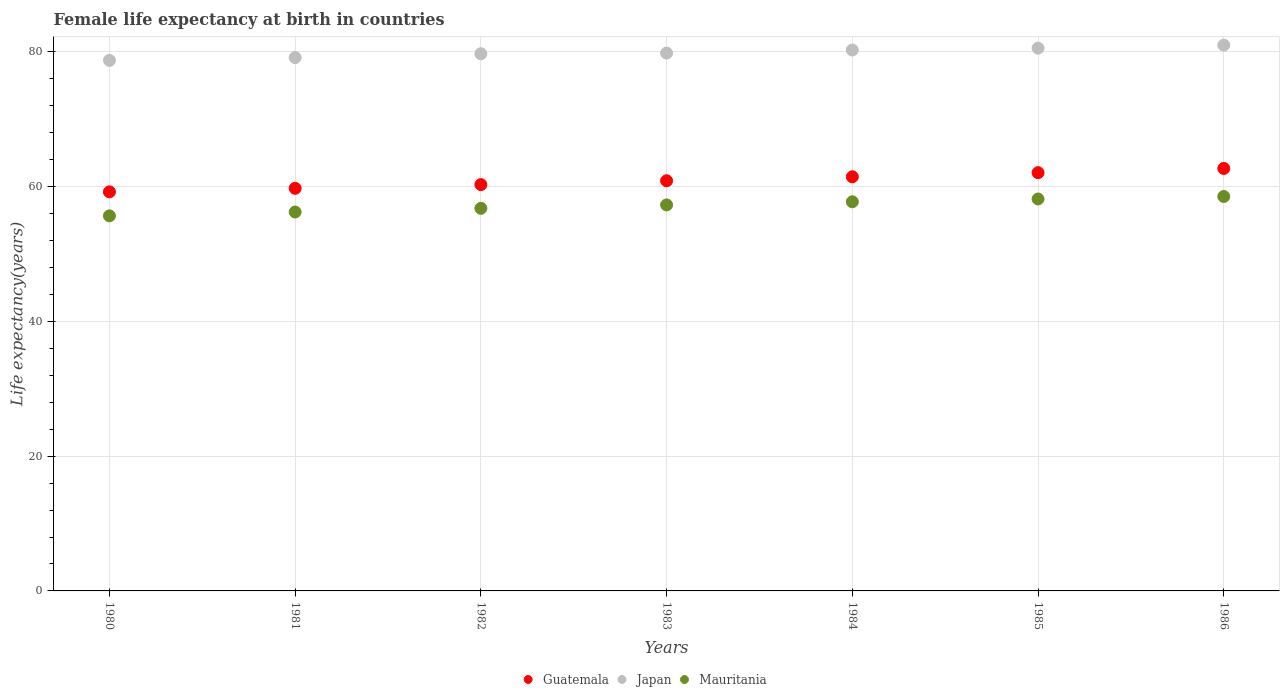What is the female life expectancy at birth in Japan in 1986?
Provide a short and direct response. 81.02. Across all years, what is the maximum female life expectancy at birth in Japan?
Your response must be concise. 81.02. Across all years, what is the minimum female life expectancy at birth in Japan?
Your answer should be compact. 78.75. In which year was the female life expectancy at birth in Japan minimum?
Your answer should be compact. 1980. What is the total female life expectancy at birth in Japan in the graph?
Provide a short and direct response. 559.38. What is the difference between the female life expectancy at birth in Japan in 1981 and that in 1982?
Your answer should be very brief. -0.57. What is the difference between the female life expectancy at birth in Japan in 1984 and the female life expectancy at birth in Guatemala in 1982?
Ensure brevity in your answer.  19.98. What is the average female life expectancy at birth in Japan per year?
Your response must be concise. 79.91. In the year 1982, what is the difference between the female life expectancy at birth in Mauritania and female life expectancy at birth in Guatemala?
Make the answer very short. -3.52. In how many years, is the female life expectancy at birth in Japan greater than 44 years?
Keep it short and to the point. 7. What is the ratio of the female life expectancy at birth in Guatemala in 1981 to that in 1982?
Offer a very short reply. 0.99. Is the female life expectancy at birth in Guatemala in 1983 less than that in 1986?
Give a very brief answer. Yes. What is the difference between the highest and the second highest female life expectancy at birth in Japan?
Keep it short and to the point. 0.45. What is the difference between the highest and the lowest female life expectancy at birth in Japan?
Give a very brief answer. 2.27. In how many years, is the female life expectancy at birth in Mauritania greater than the average female life expectancy at birth in Mauritania taken over all years?
Offer a very short reply. 4. Is the sum of the female life expectancy at birth in Japan in 1983 and 1985 greater than the maximum female life expectancy at birth in Mauritania across all years?
Give a very brief answer. Yes. Does the female life expectancy at birth in Guatemala monotonically increase over the years?
Offer a terse response. Yes. Is the female life expectancy at birth in Guatemala strictly less than the female life expectancy at birth in Japan over the years?
Offer a very short reply. Yes. What is the difference between two consecutive major ticks on the Y-axis?
Your answer should be compact. 20. Does the graph contain any zero values?
Your answer should be very brief. No. Does the graph contain grids?
Your answer should be very brief. Yes. How are the legend labels stacked?
Provide a short and direct response. Horizontal. What is the title of the graph?
Keep it short and to the point. Female life expectancy at birth in countries. Does "Costa Rica" appear as one of the legend labels in the graph?
Make the answer very short. No. What is the label or title of the Y-axis?
Your answer should be very brief. Life expectancy(years). What is the Life expectancy(years) in Guatemala in 1980?
Provide a succinct answer. 59.24. What is the Life expectancy(years) of Japan in 1980?
Make the answer very short. 78.75. What is the Life expectancy(years) of Mauritania in 1980?
Your response must be concise. 55.67. What is the Life expectancy(years) of Guatemala in 1981?
Provide a short and direct response. 59.76. What is the Life expectancy(years) of Japan in 1981?
Your response must be concise. 79.17. What is the Life expectancy(years) in Mauritania in 1981?
Ensure brevity in your answer.  56.25. What is the Life expectancy(years) of Guatemala in 1982?
Offer a very short reply. 60.31. What is the Life expectancy(years) in Japan in 1982?
Your answer should be very brief. 79.74. What is the Life expectancy(years) in Mauritania in 1982?
Ensure brevity in your answer.  56.79. What is the Life expectancy(years) of Guatemala in 1983?
Your answer should be very brief. 60.88. What is the Life expectancy(years) in Japan in 1983?
Your answer should be compact. 79.84. What is the Life expectancy(years) of Mauritania in 1983?
Your answer should be very brief. 57.3. What is the Life expectancy(years) of Guatemala in 1984?
Give a very brief answer. 61.48. What is the Life expectancy(years) of Japan in 1984?
Your answer should be compact. 80.29. What is the Life expectancy(years) in Mauritania in 1984?
Provide a short and direct response. 57.76. What is the Life expectancy(years) of Guatemala in 1985?
Provide a short and direct response. 62.09. What is the Life expectancy(years) in Japan in 1985?
Offer a very short reply. 80.57. What is the Life expectancy(years) of Mauritania in 1985?
Your answer should be very brief. 58.18. What is the Life expectancy(years) in Guatemala in 1986?
Provide a short and direct response. 62.71. What is the Life expectancy(years) of Japan in 1986?
Keep it short and to the point. 81.02. What is the Life expectancy(years) of Mauritania in 1986?
Offer a very short reply. 58.55. Across all years, what is the maximum Life expectancy(years) in Guatemala?
Provide a short and direct response. 62.71. Across all years, what is the maximum Life expectancy(years) in Japan?
Keep it short and to the point. 81.02. Across all years, what is the maximum Life expectancy(years) of Mauritania?
Provide a succinct answer. 58.55. Across all years, what is the minimum Life expectancy(years) in Guatemala?
Make the answer very short. 59.24. Across all years, what is the minimum Life expectancy(years) of Japan?
Make the answer very short. 78.75. Across all years, what is the minimum Life expectancy(years) in Mauritania?
Make the answer very short. 55.67. What is the total Life expectancy(years) of Guatemala in the graph?
Your answer should be compact. 426.47. What is the total Life expectancy(years) in Japan in the graph?
Ensure brevity in your answer.  559.38. What is the total Life expectancy(years) in Mauritania in the graph?
Your answer should be very brief. 400.5. What is the difference between the Life expectancy(years) of Guatemala in 1980 and that in 1981?
Keep it short and to the point. -0.53. What is the difference between the Life expectancy(years) of Japan in 1980 and that in 1981?
Your response must be concise. -0.42. What is the difference between the Life expectancy(years) of Mauritania in 1980 and that in 1981?
Your answer should be compact. -0.57. What is the difference between the Life expectancy(years) in Guatemala in 1980 and that in 1982?
Your response must be concise. -1.07. What is the difference between the Life expectancy(years) of Japan in 1980 and that in 1982?
Keep it short and to the point. -0.99. What is the difference between the Life expectancy(years) of Mauritania in 1980 and that in 1982?
Ensure brevity in your answer.  -1.12. What is the difference between the Life expectancy(years) of Guatemala in 1980 and that in 1983?
Your answer should be very brief. -1.65. What is the difference between the Life expectancy(years) in Japan in 1980 and that in 1983?
Your answer should be compact. -1.09. What is the difference between the Life expectancy(years) of Mauritania in 1980 and that in 1983?
Keep it short and to the point. -1.63. What is the difference between the Life expectancy(years) in Guatemala in 1980 and that in 1984?
Make the answer very short. -2.24. What is the difference between the Life expectancy(years) in Japan in 1980 and that in 1984?
Offer a terse response. -1.54. What is the difference between the Life expectancy(years) in Mauritania in 1980 and that in 1984?
Provide a succinct answer. -2.09. What is the difference between the Life expectancy(years) in Guatemala in 1980 and that in 1985?
Your answer should be compact. -2.85. What is the difference between the Life expectancy(years) of Japan in 1980 and that in 1985?
Offer a terse response. -1.82. What is the difference between the Life expectancy(years) of Mauritania in 1980 and that in 1985?
Offer a very short reply. -2.51. What is the difference between the Life expectancy(years) of Guatemala in 1980 and that in 1986?
Ensure brevity in your answer.  -3.47. What is the difference between the Life expectancy(years) in Japan in 1980 and that in 1986?
Offer a very short reply. -2.27. What is the difference between the Life expectancy(years) of Mauritania in 1980 and that in 1986?
Your answer should be compact. -2.88. What is the difference between the Life expectancy(years) in Guatemala in 1981 and that in 1982?
Make the answer very short. -0.55. What is the difference between the Life expectancy(years) in Japan in 1981 and that in 1982?
Your answer should be compact. -0.57. What is the difference between the Life expectancy(years) of Mauritania in 1981 and that in 1982?
Your answer should be compact. -0.55. What is the difference between the Life expectancy(years) in Guatemala in 1981 and that in 1983?
Provide a succinct answer. -1.12. What is the difference between the Life expectancy(years) of Japan in 1981 and that in 1983?
Offer a terse response. -0.67. What is the difference between the Life expectancy(years) of Mauritania in 1981 and that in 1983?
Your answer should be very brief. -1.05. What is the difference between the Life expectancy(years) in Guatemala in 1981 and that in 1984?
Offer a very short reply. -1.71. What is the difference between the Life expectancy(years) of Japan in 1981 and that in 1984?
Offer a very short reply. -1.12. What is the difference between the Life expectancy(years) of Mauritania in 1981 and that in 1984?
Provide a short and direct response. -1.52. What is the difference between the Life expectancy(years) in Guatemala in 1981 and that in 1985?
Provide a succinct answer. -2.32. What is the difference between the Life expectancy(years) in Mauritania in 1981 and that in 1985?
Ensure brevity in your answer.  -1.94. What is the difference between the Life expectancy(years) in Guatemala in 1981 and that in 1986?
Offer a very short reply. -2.94. What is the difference between the Life expectancy(years) in Japan in 1981 and that in 1986?
Ensure brevity in your answer.  -1.85. What is the difference between the Life expectancy(years) in Mauritania in 1981 and that in 1986?
Offer a terse response. -2.3. What is the difference between the Life expectancy(years) of Guatemala in 1982 and that in 1983?
Make the answer very short. -0.57. What is the difference between the Life expectancy(years) of Mauritania in 1982 and that in 1983?
Ensure brevity in your answer.  -0.51. What is the difference between the Life expectancy(years) in Guatemala in 1982 and that in 1984?
Offer a terse response. -1.16. What is the difference between the Life expectancy(years) of Japan in 1982 and that in 1984?
Make the answer very short. -0.55. What is the difference between the Life expectancy(years) in Mauritania in 1982 and that in 1984?
Offer a very short reply. -0.97. What is the difference between the Life expectancy(years) in Guatemala in 1982 and that in 1985?
Ensure brevity in your answer.  -1.77. What is the difference between the Life expectancy(years) in Japan in 1982 and that in 1985?
Offer a very short reply. -0.83. What is the difference between the Life expectancy(years) of Mauritania in 1982 and that in 1985?
Keep it short and to the point. -1.39. What is the difference between the Life expectancy(years) in Guatemala in 1982 and that in 1986?
Offer a very short reply. -2.4. What is the difference between the Life expectancy(years) of Japan in 1982 and that in 1986?
Make the answer very short. -1.28. What is the difference between the Life expectancy(years) in Mauritania in 1982 and that in 1986?
Provide a succinct answer. -1.76. What is the difference between the Life expectancy(years) of Guatemala in 1983 and that in 1984?
Give a very brief answer. -0.59. What is the difference between the Life expectancy(years) of Japan in 1983 and that in 1984?
Provide a short and direct response. -0.45. What is the difference between the Life expectancy(years) in Mauritania in 1983 and that in 1984?
Offer a very short reply. -0.47. What is the difference between the Life expectancy(years) of Guatemala in 1983 and that in 1985?
Provide a succinct answer. -1.2. What is the difference between the Life expectancy(years) in Japan in 1983 and that in 1985?
Your answer should be compact. -0.73. What is the difference between the Life expectancy(years) in Mauritania in 1983 and that in 1985?
Give a very brief answer. -0.88. What is the difference between the Life expectancy(years) of Guatemala in 1983 and that in 1986?
Your answer should be very brief. -1.82. What is the difference between the Life expectancy(years) in Japan in 1983 and that in 1986?
Provide a short and direct response. -1.18. What is the difference between the Life expectancy(years) in Mauritania in 1983 and that in 1986?
Give a very brief answer. -1.25. What is the difference between the Life expectancy(years) of Guatemala in 1984 and that in 1985?
Make the answer very short. -0.61. What is the difference between the Life expectancy(years) in Japan in 1984 and that in 1985?
Your answer should be very brief. -0.28. What is the difference between the Life expectancy(years) in Mauritania in 1984 and that in 1985?
Offer a very short reply. -0.42. What is the difference between the Life expectancy(years) in Guatemala in 1984 and that in 1986?
Keep it short and to the point. -1.23. What is the difference between the Life expectancy(years) of Japan in 1984 and that in 1986?
Provide a succinct answer. -0.73. What is the difference between the Life expectancy(years) of Mauritania in 1984 and that in 1986?
Offer a very short reply. -0.79. What is the difference between the Life expectancy(years) in Guatemala in 1985 and that in 1986?
Make the answer very short. -0.62. What is the difference between the Life expectancy(years) of Japan in 1985 and that in 1986?
Give a very brief answer. -0.45. What is the difference between the Life expectancy(years) in Mauritania in 1985 and that in 1986?
Make the answer very short. -0.37. What is the difference between the Life expectancy(years) of Guatemala in 1980 and the Life expectancy(years) of Japan in 1981?
Make the answer very short. -19.93. What is the difference between the Life expectancy(years) in Guatemala in 1980 and the Life expectancy(years) in Mauritania in 1981?
Ensure brevity in your answer.  2.99. What is the difference between the Life expectancy(years) in Japan in 1980 and the Life expectancy(years) in Mauritania in 1981?
Your response must be concise. 22.5. What is the difference between the Life expectancy(years) of Guatemala in 1980 and the Life expectancy(years) of Japan in 1982?
Ensure brevity in your answer.  -20.5. What is the difference between the Life expectancy(years) of Guatemala in 1980 and the Life expectancy(years) of Mauritania in 1982?
Offer a terse response. 2.45. What is the difference between the Life expectancy(years) of Japan in 1980 and the Life expectancy(years) of Mauritania in 1982?
Give a very brief answer. 21.96. What is the difference between the Life expectancy(years) of Guatemala in 1980 and the Life expectancy(years) of Japan in 1983?
Your answer should be very brief. -20.6. What is the difference between the Life expectancy(years) in Guatemala in 1980 and the Life expectancy(years) in Mauritania in 1983?
Your response must be concise. 1.94. What is the difference between the Life expectancy(years) of Japan in 1980 and the Life expectancy(years) of Mauritania in 1983?
Give a very brief answer. 21.45. What is the difference between the Life expectancy(years) of Guatemala in 1980 and the Life expectancy(years) of Japan in 1984?
Your response must be concise. -21.05. What is the difference between the Life expectancy(years) of Guatemala in 1980 and the Life expectancy(years) of Mauritania in 1984?
Keep it short and to the point. 1.48. What is the difference between the Life expectancy(years) in Japan in 1980 and the Life expectancy(years) in Mauritania in 1984?
Offer a very short reply. 20.99. What is the difference between the Life expectancy(years) in Guatemala in 1980 and the Life expectancy(years) in Japan in 1985?
Offer a terse response. -21.33. What is the difference between the Life expectancy(years) in Guatemala in 1980 and the Life expectancy(years) in Mauritania in 1985?
Offer a very short reply. 1.06. What is the difference between the Life expectancy(years) in Japan in 1980 and the Life expectancy(years) in Mauritania in 1985?
Make the answer very short. 20.57. What is the difference between the Life expectancy(years) in Guatemala in 1980 and the Life expectancy(years) in Japan in 1986?
Offer a very short reply. -21.78. What is the difference between the Life expectancy(years) in Guatemala in 1980 and the Life expectancy(years) in Mauritania in 1986?
Offer a terse response. 0.69. What is the difference between the Life expectancy(years) of Japan in 1980 and the Life expectancy(years) of Mauritania in 1986?
Give a very brief answer. 20.2. What is the difference between the Life expectancy(years) of Guatemala in 1981 and the Life expectancy(years) of Japan in 1982?
Offer a very short reply. -19.98. What is the difference between the Life expectancy(years) of Guatemala in 1981 and the Life expectancy(years) of Mauritania in 1982?
Make the answer very short. 2.97. What is the difference between the Life expectancy(years) of Japan in 1981 and the Life expectancy(years) of Mauritania in 1982?
Keep it short and to the point. 22.38. What is the difference between the Life expectancy(years) of Guatemala in 1981 and the Life expectancy(years) of Japan in 1983?
Provide a succinct answer. -20.08. What is the difference between the Life expectancy(years) in Guatemala in 1981 and the Life expectancy(years) in Mauritania in 1983?
Your response must be concise. 2.46. What is the difference between the Life expectancy(years) in Japan in 1981 and the Life expectancy(years) in Mauritania in 1983?
Your answer should be very brief. 21.87. What is the difference between the Life expectancy(years) in Guatemala in 1981 and the Life expectancy(years) in Japan in 1984?
Your response must be concise. -20.53. What is the difference between the Life expectancy(years) of Guatemala in 1981 and the Life expectancy(years) of Mauritania in 1984?
Your response must be concise. 2. What is the difference between the Life expectancy(years) in Japan in 1981 and the Life expectancy(years) in Mauritania in 1984?
Offer a terse response. 21.41. What is the difference between the Life expectancy(years) of Guatemala in 1981 and the Life expectancy(years) of Japan in 1985?
Give a very brief answer. -20.81. What is the difference between the Life expectancy(years) in Guatemala in 1981 and the Life expectancy(years) in Mauritania in 1985?
Provide a short and direct response. 1.58. What is the difference between the Life expectancy(years) of Japan in 1981 and the Life expectancy(years) of Mauritania in 1985?
Make the answer very short. 20.99. What is the difference between the Life expectancy(years) of Guatemala in 1981 and the Life expectancy(years) of Japan in 1986?
Provide a succinct answer. -21.26. What is the difference between the Life expectancy(years) of Guatemala in 1981 and the Life expectancy(years) of Mauritania in 1986?
Make the answer very short. 1.22. What is the difference between the Life expectancy(years) of Japan in 1981 and the Life expectancy(years) of Mauritania in 1986?
Give a very brief answer. 20.62. What is the difference between the Life expectancy(years) of Guatemala in 1982 and the Life expectancy(years) of Japan in 1983?
Your answer should be compact. -19.53. What is the difference between the Life expectancy(years) in Guatemala in 1982 and the Life expectancy(years) in Mauritania in 1983?
Your answer should be very brief. 3.02. What is the difference between the Life expectancy(years) in Japan in 1982 and the Life expectancy(years) in Mauritania in 1983?
Keep it short and to the point. 22.44. What is the difference between the Life expectancy(years) in Guatemala in 1982 and the Life expectancy(years) in Japan in 1984?
Keep it short and to the point. -19.98. What is the difference between the Life expectancy(years) of Guatemala in 1982 and the Life expectancy(years) of Mauritania in 1984?
Offer a very short reply. 2.55. What is the difference between the Life expectancy(years) of Japan in 1982 and the Life expectancy(years) of Mauritania in 1984?
Keep it short and to the point. 21.98. What is the difference between the Life expectancy(years) of Guatemala in 1982 and the Life expectancy(years) of Japan in 1985?
Your response must be concise. -20.26. What is the difference between the Life expectancy(years) in Guatemala in 1982 and the Life expectancy(years) in Mauritania in 1985?
Give a very brief answer. 2.13. What is the difference between the Life expectancy(years) of Japan in 1982 and the Life expectancy(years) of Mauritania in 1985?
Provide a succinct answer. 21.56. What is the difference between the Life expectancy(years) in Guatemala in 1982 and the Life expectancy(years) in Japan in 1986?
Offer a terse response. -20.71. What is the difference between the Life expectancy(years) in Guatemala in 1982 and the Life expectancy(years) in Mauritania in 1986?
Offer a very short reply. 1.76. What is the difference between the Life expectancy(years) in Japan in 1982 and the Life expectancy(years) in Mauritania in 1986?
Your response must be concise. 21.19. What is the difference between the Life expectancy(years) of Guatemala in 1983 and the Life expectancy(years) of Japan in 1984?
Give a very brief answer. -19.41. What is the difference between the Life expectancy(years) in Guatemala in 1983 and the Life expectancy(years) in Mauritania in 1984?
Give a very brief answer. 3.12. What is the difference between the Life expectancy(years) of Japan in 1983 and the Life expectancy(years) of Mauritania in 1984?
Make the answer very short. 22.08. What is the difference between the Life expectancy(years) of Guatemala in 1983 and the Life expectancy(years) of Japan in 1985?
Offer a very short reply. -19.69. What is the difference between the Life expectancy(years) in Guatemala in 1983 and the Life expectancy(years) in Mauritania in 1985?
Provide a succinct answer. 2.7. What is the difference between the Life expectancy(years) of Japan in 1983 and the Life expectancy(years) of Mauritania in 1985?
Make the answer very short. 21.66. What is the difference between the Life expectancy(years) of Guatemala in 1983 and the Life expectancy(years) of Japan in 1986?
Offer a very short reply. -20.14. What is the difference between the Life expectancy(years) of Guatemala in 1983 and the Life expectancy(years) of Mauritania in 1986?
Keep it short and to the point. 2.33. What is the difference between the Life expectancy(years) in Japan in 1983 and the Life expectancy(years) in Mauritania in 1986?
Your answer should be very brief. 21.29. What is the difference between the Life expectancy(years) in Guatemala in 1984 and the Life expectancy(years) in Japan in 1985?
Provide a succinct answer. -19.09. What is the difference between the Life expectancy(years) in Guatemala in 1984 and the Life expectancy(years) in Mauritania in 1985?
Your answer should be compact. 3.29. What is the difference between the Life expectancy(years) in Japan in 1984 and the Life expectancy(years) in Mauritania in 1985?
Offer a very short reply. 22.11. What is the difference between the Life expectancy(years) of Guatemala in 1984 and the Life expectancy(years) of Japan in 1986?
Make the answer very short. -19.54. What is the difference between the Life expectancy(years) of Guatemala in 1984 and the Life expectancy(years) of Mauritania in 1986?
Your response must be concise. 2.93. What is the difference between the Life expectancy(years) of Japan in 1984 and the Life expectancy(years) of Mauritania in 1986?
Offer a very short reply. 21.74. What is the difference between the Life expectancy(years) of Guatemala in 1985 and the Life expectancy(years) of Japan in 1986?
Provide a succinct answer. -18.93. What is the difference between the Life expectancy(years) of Guatemala in 1985 and the Life expectancy(years) of Mauritania in 1986?
Ensure brevity in your answer.  3.54. What is the difference between the Life expectancy(years) of Japan in 1985 and the Life expectancy(years) of Mauritania in 1986?
Provide a succinct answer. 22.02. What is the average Life expectancy(years) of Guatemala per year?
Your answer should be compact. 60.92. What is the average Life expectancy(years) in Japan per year?
Provide a succinct answer. 79.91. What is the average Life expectancy(years) of Mauritania per year?
Provide a succinct answer. 57.21. In the year 1980, what is the difference between the Life expectancy(years) in Guatemala and Life expectancy(years) in Japan?
Provide a short and direct response. -19.51. In the year 1980, what is the difference between the Life expectancy(years) of Guatemala and Life expectancy(years) of Mauritania?
Ensure brevity in your answer.  3.57. In the year 1980, what is the difference between the Life expectancy(years) in Japan and Life expectancy(years) in Mauritania?
Offer a terse response. 23.08. In the year 1981, what is the difference between the Life expectancy(years) in Guatemala and Life expectancy(years) in Japan?
Keep it short and to the point. -19.41. In the year 1981, what is the difference between the Life expectancy(years) in Guatemala and Life expectancy(years) in Mauritania?
Your answer should be very brief. 3.52. In the year 1981, what is the difference between the Life expectancy(years) of Japan and Life expectancy(years) of Mauritania?
Ensure brevity in your answer.  22.92. In the year 1982, what is the difference between the Life expectancy(years) of Guatemala and Life expectancy(years) of Japan?
Provide a succinct answer. -19.43. In the year 1982, what is the difference between the Life expectancy(years) in Guatemala and Life expectancy(years) in Mauritania?
Make the answer very short. 3.52. In the year 1982, what is the difference between the Life expectancy(years) of Japan and Life expectancy(years) of Mauritania?
Your response must be concise. 22.95. In the year 1983, what is the difference between the Life expectancy(years) of Guatemala and Life expectancy(years) of Japan?
Ensure brevity in your answer.  -18.96. In the year 1983, what is the difference between the Life expectancy(years) of Guatemala and Life expectancy(years) of Mauritania?
Offer a terse response. 3.58. In the year 1983, what is the difference between the Life expectancy(years) in Japan and Life expectancy(years) in Mauritania?
Ensure brevity in your answer.  22.54. In the year 1984, what is the difference between the Life expectancy(years) in Guatemala and Life expectancy(years) in Japan?
Your answer should be compact. -18.81. In the year 1984, what is the difference between the Life expectancy(years) in Guatemala and Life expectancy(years) in Mauritania?
Keep it short and to the point. 3.71. In the year 1984, what is the difference between the Life expectancy(years) in Japan and Life expectancy(years) in Mauritania?
Provide a short and direct response. 22.53. In the year 1985, what is the difference between the Life expectancy(years) of Guatemala and Life expectancy(years) of Japan?
Your answer should be compact. -18.48. In the year 1985, what is the difference between the Life expectancy(years) in Guatemala and Life expectancy(years) in Mauritania?
Your answer should be compact. 3.9. In the year 1985, what is the difference between the Life expectancy(years) of Japan and Life expectancy(years) of Mauritania?
Provide a short and direct response. 22.39. In the year 1986, what is the difference between the Life expectancy(years) of Guatemala and Life expectancy(years) of Japan?
Give a very brief answer. -18.31. In the year 1986, what is the difference between the Life expectancy(years) of Guatemala and Life expectancy(years) of Mauritania?
Your response must be concise. 4.16. In the year 1986, what is the difference between the Life expectancy(years) of Japan and Life expectancy(years) of Mauritania?
Your answer should be very brief. 22.47. What is the ratio of the Life expectancy(years) in Guatemala in 1980 to that in 1981?
Your response must be concise. 0.99. What is the ratio of the Life expectancy(years) in Guatemala in 1980 to that in 1982?
Make the answer very short. 0.98. What is the ratio of the Life expectancy(years) of Japan in 1980 to that in 1982?
Give a very brief answer. 0.99. What is the ratio of the Life expectancy(years) of Mauritania in 1980 to that in 1982?
Make the answer very short. 0.98. What is the ratio of the Life expectancy(years) in Guatemala in 1980 to that in 1983?
Your answer should be compact. 0.97. What is the ratio of the Life expectancy(years) of Japan in 1980 to that in 1983?
Ensure brevity in your answer.  0.99. What is the ratio of the Life expectancy(years) in Mauritania in 1980 to that in 1983?
Provide a succinct answer. 0.97. What is the ratio of the Life expectancy(years) in Guatemala in 1980 to that in 1984?
Provide a succinct answer. 0.96. What is the ratio of the Life expectancy(years) in Japan in 1980 to that in 1984?
Make the answer very short. 0.98. What is the ratio of the Life expectancy(years) in Mauritania in 1980 to that in 1984?
Offer a very short reply. 0.96. What is the ratio of the Life expectancy(years) in Guatemala in 1980 to that in 1985?
Provide a short and direct response. 0.95. What is the ratio of the Life expectancy(years) of Japan in 1980 to that in 1985?
Make the answer very short. 0.98. What is the ratio of the Life expectancy(years) of Mauritania in 1980 to that in 1985?
Offer a terse response. 0.96. What is the ratio of the Life expectancy(years) in Guatemala in 1980 to that in 1986?
Offer a terse response. 0.94. What is the ratio of the Life expectancy(years) of Mauritania in 1980 to that in 1986?
Ensure brevity in your answer.  0.95. What is the ratio of the Life expectancy(years) in Guatemala in 1981 to that in 1982?
Your answer should be compact. 0.99. What is the ratio of the Life expectancy(years) of Japan in 1981 to that in 1982?
Offer a terse response. 0.99. What is the ratio of the Life expectancy(years) of Guatemala in 1981 to that in 1983?
Give a very brief answer. 0.98. What is the ratio of the Life expectancy(years) in Mauritania in 1981 to that in 1983?
Your response must be concise. 0.98. What is the ratio of the Life expectancy(years) in Guatemala in 1981 to that in 1984?
Offer a terse response. 0.97. What is the ratio of the Life expectancy(years) of Japan in 1981 to that in 1984?
Give a very brief answer. 0.99. What is the ratio of the Life expectancy(years) of Mauritania in 1981 to that in 1984?
Offer a very short reply. 0.97. What is the ratio of the Life expectancy(years) in Guatemala in 1981 to that in 1985?
Ensure brevity in your answer.  0.96. What is the ratio of the Life expectancy(years) in Japan in 1981 to that in 1985?
Offer a very short reply. 0.98. What is the ratio of the Life expectancy(years) of Mauritania in 1981 to that in 1985?
Offer a terse response. 0.97. What is the ratio of the Life expectancy(years) in Guatemala in 1981 to that in 1986?
Your answer should be very brief. 0.95. What is the ratio of the Life expectancy(years) of Japan in 1981 to that in 1986?
Keep it short and to the point. 0.98. What is the ratio of the Life expectancy(years) of Mauritania in 1981 to that in 1986?
Your response must be concise. 0.96. What is the ratio of the Life expectancy(years) in Guatemala in 1982 to that in 1983?
Offer a very short reply. 0.99. What is the ratio of the Life expectancy(years) of Mauritania in 1982 to that in 1983?
Offer a very short reply. 0.99. What is the ratio of the Life expectancy(years) of Guatemala in 1982 to that in 1984?
Keep it short and to the point. 0.98. What is the ratio of the Life expectancy(years) of Japan in 1982 to that in 1984?
Make the answer very short. 0.99. What is the ratio of the Life expectancy(years) of Mauritania in 1982 to that in 1984?
Make the answer very short. 0.98. What is the ratio of the Life expectancy(years) in Guatemala in 1982 to that in 1985?
Provide a succinct answer. 0.97. What is the ratio of the Life expectancy(years) of Japan in 1982 to that in 1985?
Your answer should be very brief. 0.99. What is the ratio of the Life expectancy(years) of Mauritania in 1982 to that in 1985?
Your answer should be very brief. 0.98. What is the ratio of the Life expectancy(years) in Guatemala in 1982 to that in 1986?
Your answer should be compact. 0.96. What is the ratio of the Life expectancy(years) in Japan in 1982 to that in 1986?
Your response must be concise. 0.98. What is the ratio of the Life expectancy(years) in Mauritania in 1982 to that in 1986?
Offer a terse response. 0.97. What is the ratio of the Life expectancy(years) of Guatemala in 1983 to that in 1984?
Your answer should be compact. 0.99. What is the ratio of the Life expectancy(years) of Mauritania in 1983 to that in 1984?
Keep it short and to the point. 0.99. What is the ratio of the Life expectancy(years) of Guatemala in 1983 to that in 1985?
Make the answer very short. 0.98. What is the ratio of the Life expectancy(years) of Japan in 1983 to that in 1985?
Make the answer very short. 0.99. What is the ratio of the Life expectancy(years) of Mauritania in 1983 to that in 1985?
Your answer should be compact. 0.98. What is the ratio of the Life expectancy(years) of Guatemala in 1983 to that in 1986?
Your answer should be very brief. 0.97. What is the ratio of the Life expectancy(years) of Japan in 1983 to that in 1986?
Keep it short and to the point. 0.99. What is the ratio of the Life expectancy(years) of Mauritania in 1983 to that in 1986?
Ensure brevity in your answer.  0.98. What is the ratio of the Life expectancy(years) of Guatemala in 1984 to that in 1985?
Your answer should be very brief. 0.99. What is the ratio of the Life expectancy(years) in Japan in 1984 to that in 1985?
Your response must be concise. 1. What is the ratio of the Life expectancy(years) of Guatemala in 1984 to that in 1986?
Provide a short and direct response. 0.98. What is the ratio of the Life expectancy(years) in Japan in 1984 to that in 1986?
Your answer should be compact. 0.99. What is the ratio of the Life expectancy(years) of Mauritania in 1984 to that in 1986?
Offer a terse response. 0.99. What is the ratio of the Life expectancy(years) of Guatemala in 1985 to that in 1986?
Provide a succinct answer. 0.99. What is the ratio of the Life expectancy(years) of Japan in 1985 to that in 1986?
Your answer should be compact. 0.99. What is the difference between the highest and the second highest Life expectancy(years) of Guatemala?
Your answer should be very brief. 0.62. What is the difference between the highest and the second highest Life expectancy(years) in Japan?
Offer a very short reply. 0.45. What is the difference between the highest and the second highest Life expectancy(years) of Mauritania?
Your answer should be very brief. 0.37. What is the difference between the highest and the lowest Life expectancy(years) in Guatemala?
Make the answer very short. 3.47. What is the difference between the highest and the lowest Life expectancy(years) in Japan?
Your answer should be compact. 2.27. What is the difference between the highest and the lowest Life expectancy(years) of Mauritania?
Give a very brief answer. 2.88. 